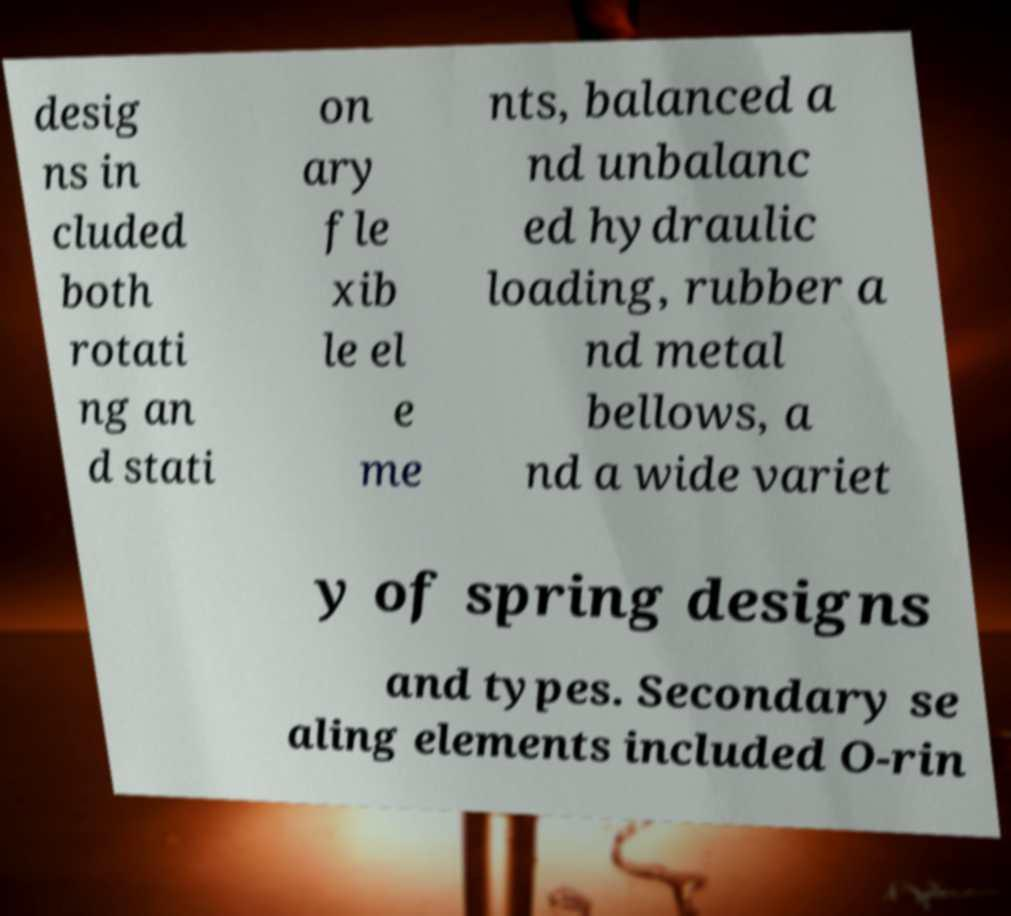I need the written content from this picture converted into text. Can you do that? desig ns in cluded both rotati ng an d stati on ary fle xib le el e me nts, balanced a nd unbalanc ed hydraulic loading, rubber a nd metal bellows, a nd a wide variet y of spring designs and types. Secondary se aling elements included O-rin 